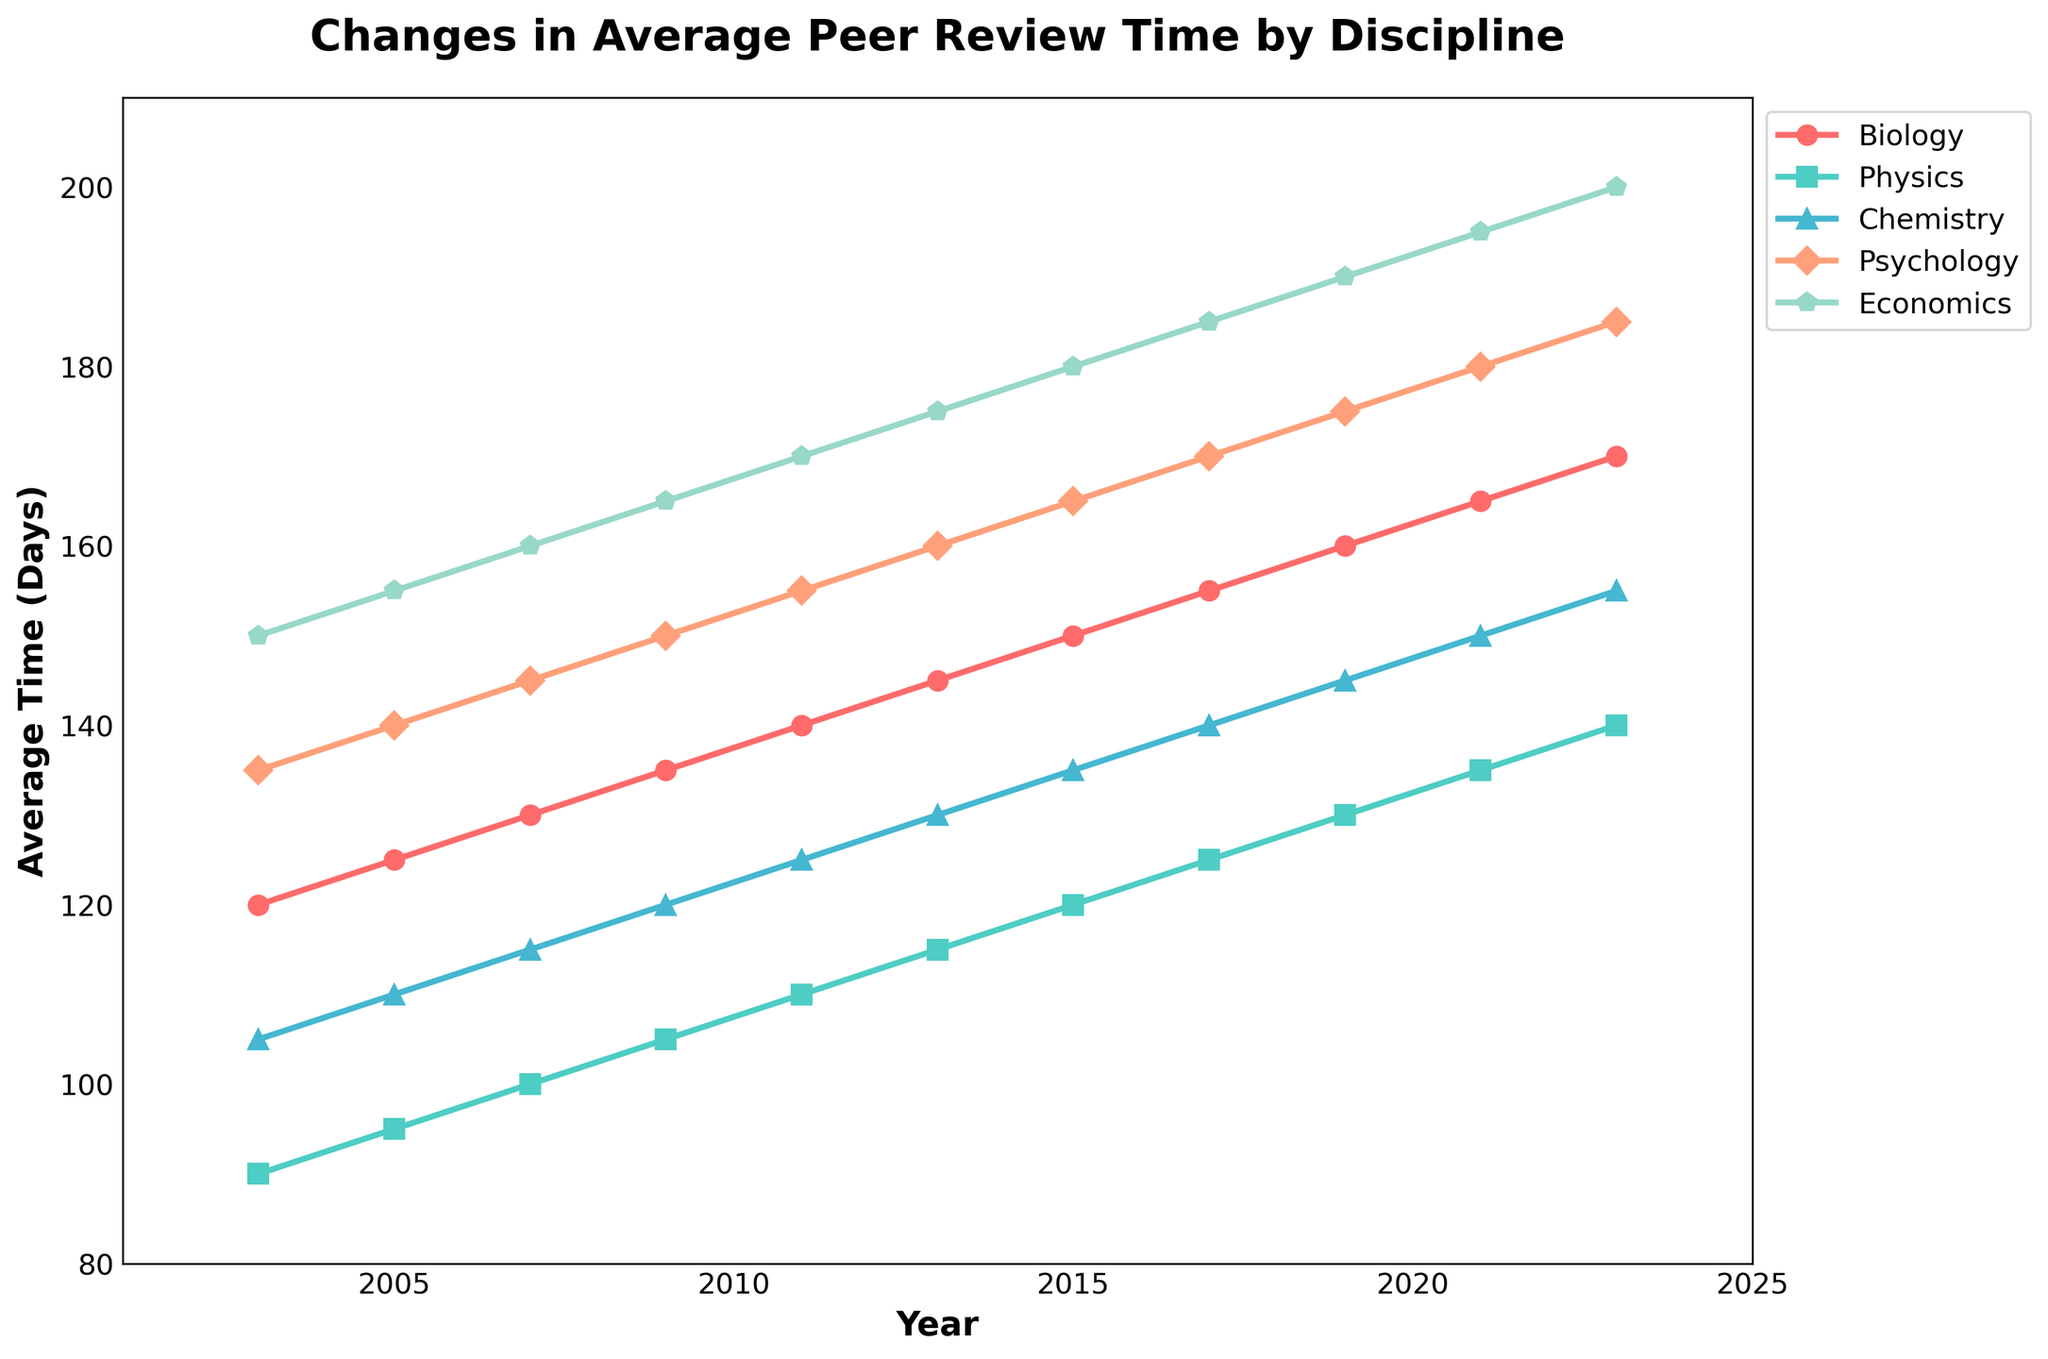What is the average peer review time across all disciplines in 2023? First, sum the review times for each discipline in 2023: 170 (Biology) + 140 (Physics) + 155 (Chemistry) + 185 (Psychology) + 200 (Economics) = 850 days. Then, divide by the number of disciplines, which is 5. So, the average is 850/5 = 170 days.
Answer: 170 days Which discipline experienced the greatest increase in average peer review time between 2003 and 2023? Calculate the difference in peer review time for each discipline between 2003 and 2023. Biology: 170 - 120 = 50 days, Physics: 140 - 90 = 50 days, Chemistry: 155 - 105 = 50 days, Psychology: 185 - 135 = 50 days, Economics: 200 - 150 = 50 days. Each discipline had an increase of 50 days.
Answer: All disciplines experienced an increase of 50 days In which year did Physics see a peer review time equal to 120 days? Locate the point on the Physics line plot where the y-axis (review time) intersects at 120 days. This occurs in the year 2015.
Answer: 2015 Which discipline had the longest average peer review time in 2009? Compare the review times for all disciplines in 2009: Biology (135), Physics (105), Chemistry (120), Psychology (150), and Economics (165). Economics had the longest average peer review time with 165 days.
Answer: Economics How much did the average peer review time in Psychology increase from 2007 to 2021? Subtract the peer review time in 2007 (145 days) from the peer review time in 2021 (180 days) for Psychology. So, 180 - 145 = 35 days.
Answer: 35 days What is the slope of the line representing the average peer review time for Chemistry between 2011 and 2017? To find the slope, use the formula (y2 - y1) / (x2 - x1). For Chemistry, the points are (2011, 125) and (2017, 140). Thus, (140 - 125) / (2017 - 2011) = 15 / 6 ≈ 2.5 days per year.
Answer: 2.5 days per year Compare the average peer review times for Biology and Economics in the year 2019. Which is greater and by how much? The peer review time for Biology in 2019 is 160 days, and for Economics, it is 190 days. Economics is greater by 190 - 160 = 30 days.
Answer: Economics is greater by 30 days Which discipline showed the smallest variation in peer review time over the 20-year period? By visual inspection, all lines seem equally spaced, indicating similar changes. However, for precise determination, a numerical analysis is required. Visually, Physics appears to have the most gradual change.
Answer: Physics In 2023, which discipline's line is marked with a pentagon? The pentagon marker is used for the Economics discipline line.
Answer: Economics 